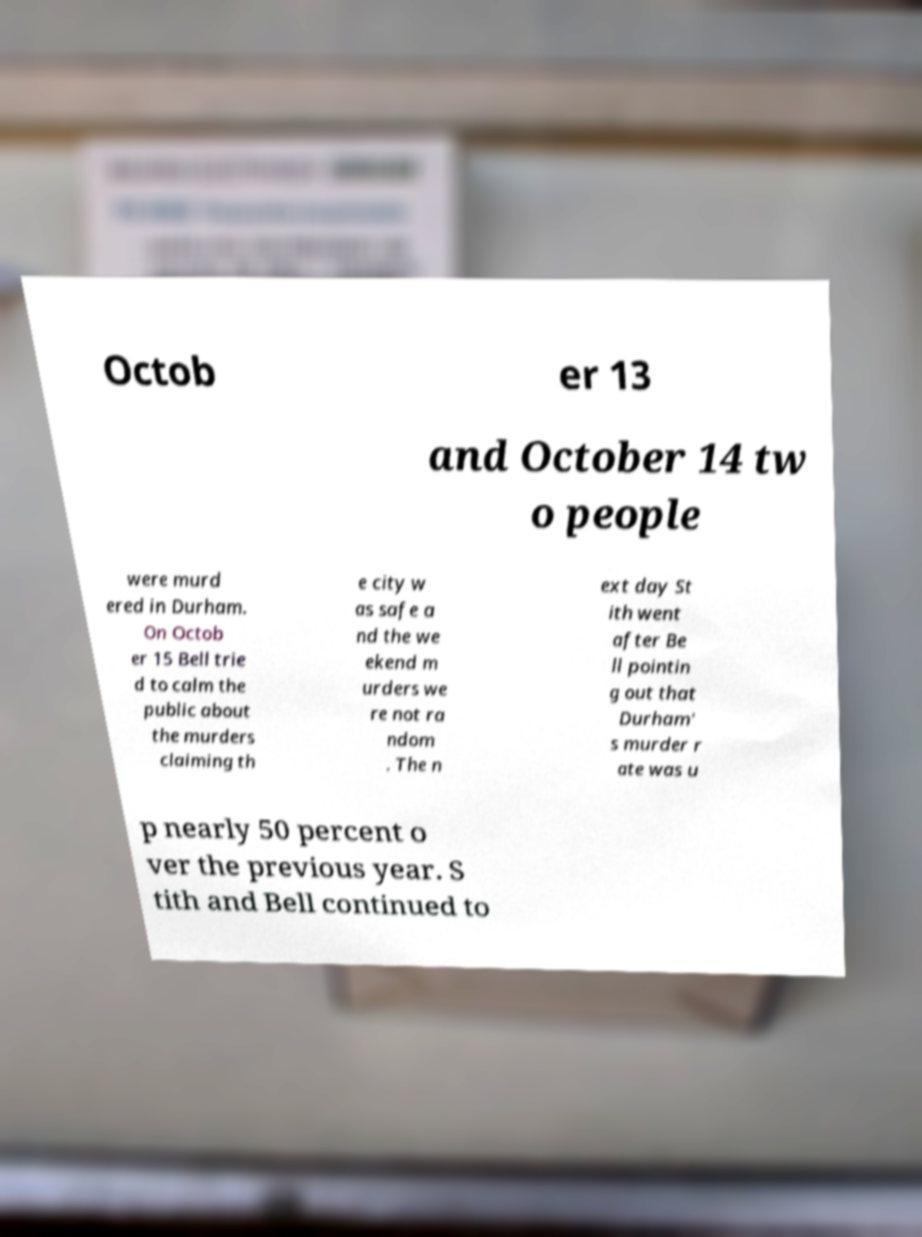Please identify and transcribe the text found in this image. Octob er 13 and October 14 tw o people were murd ered in Durham. On Octob er 15 Bell trie d to calm the public about the murders claiming th e city w as safe a nd the we ekend m urders we re not ra ndom . The n ext day St ith went after Be ll pointin g out that Durham' s murder r ate was u p nearly 50 percent o ver the previous year. S tith and Bell continued to 